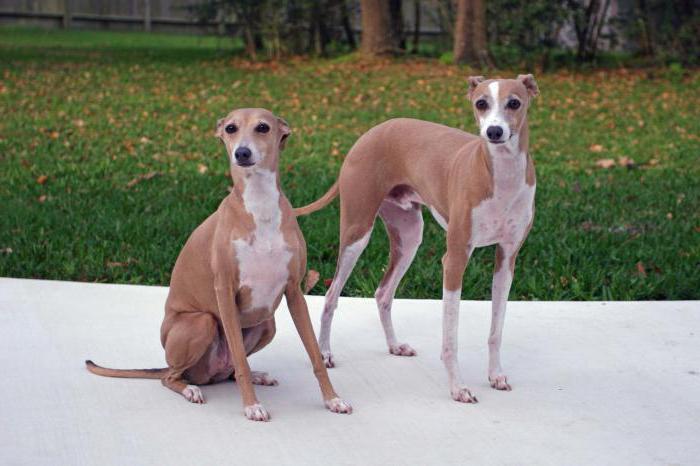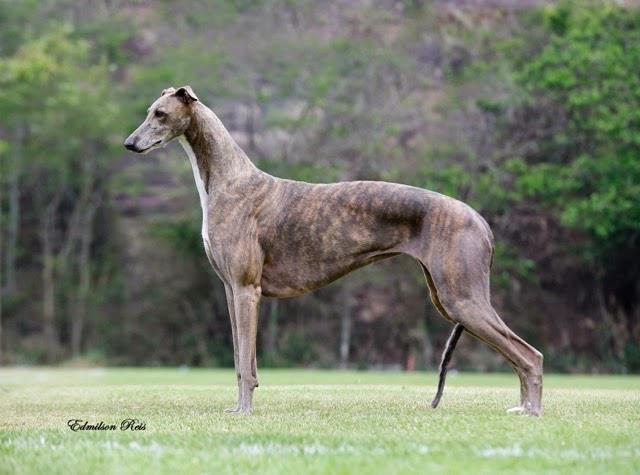The first image is the image on the left, the second image is the image on the right. Assess this claim about the two images: "the dog in the image on the left is standing on grass". Correct or not? Answer yes or no. No. The first image is the image on the left, the second image is the image on the right. For the images shown, is this caption "Left image shows a dog standing on green grass." true? Answer yes or no. No. 